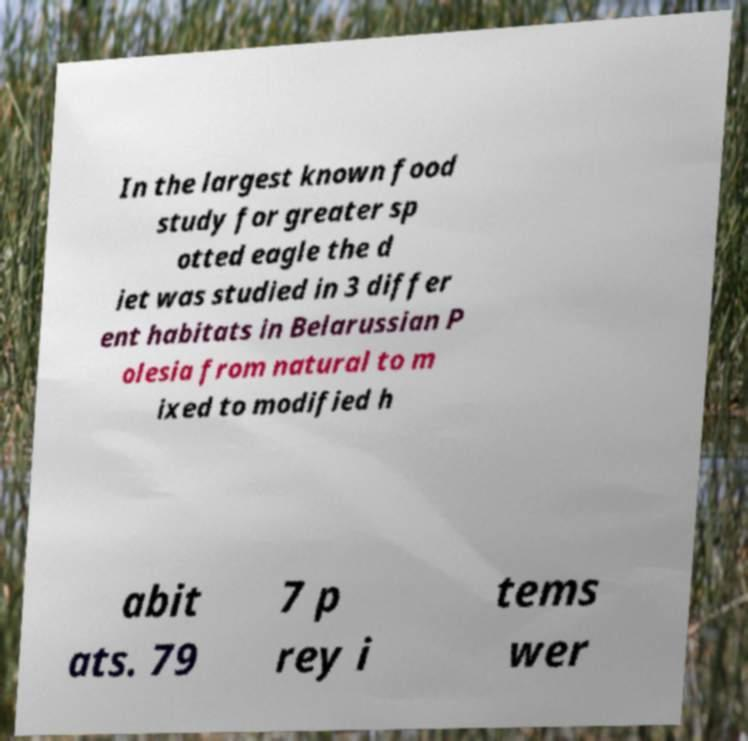Could you assist in decoding the text presented in this image and type it out clearly? In the largest known food study for greater sp otted eagle the d iet was studied in 3 differ ent habitats in Belarussian P olesia from natural to m ixed to modified h abit ats. 79 7 p rey i tems wer 